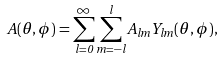<formula> <loc_0><loc_0><loc_500><loc_500>A ( \theta , \phi ) = \sum _ { l = 0 } ^ { \infty } \sum _ { m = - l } ^ { l } A _ { l m } Y _ { l m } ( \theta , \phi ) ,</formula> 